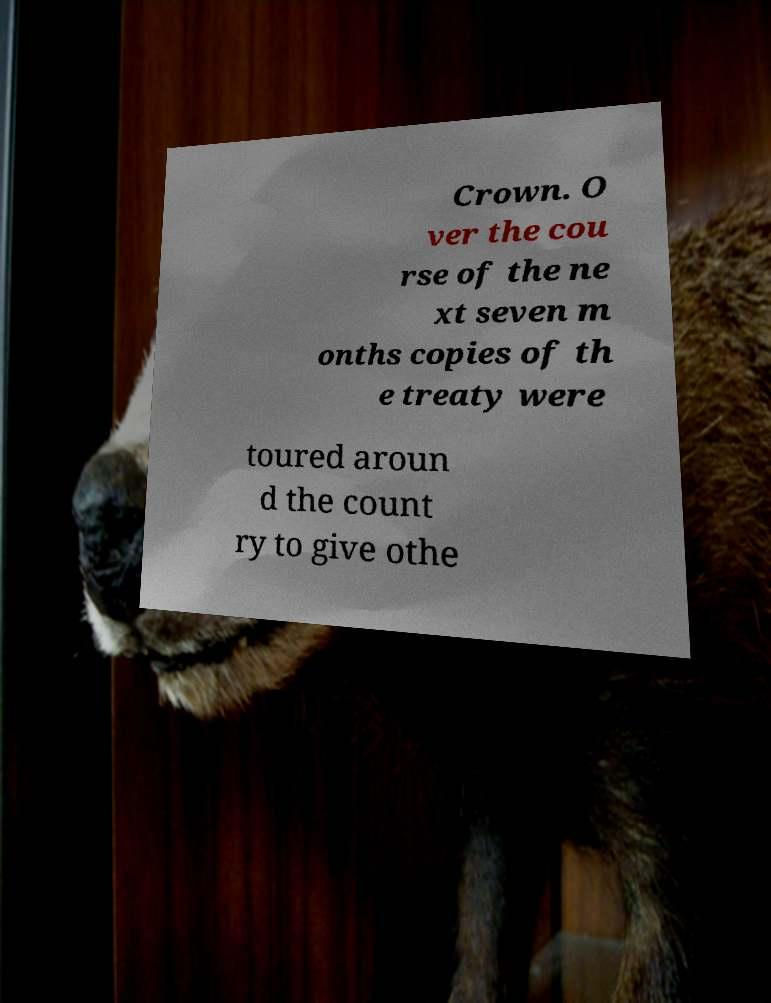Could you extract and type out the text from this image? Crown. O ver the cou rse of the ne xt seven m onths copies of th e treaty were toured aroun d the count ry to give othe 